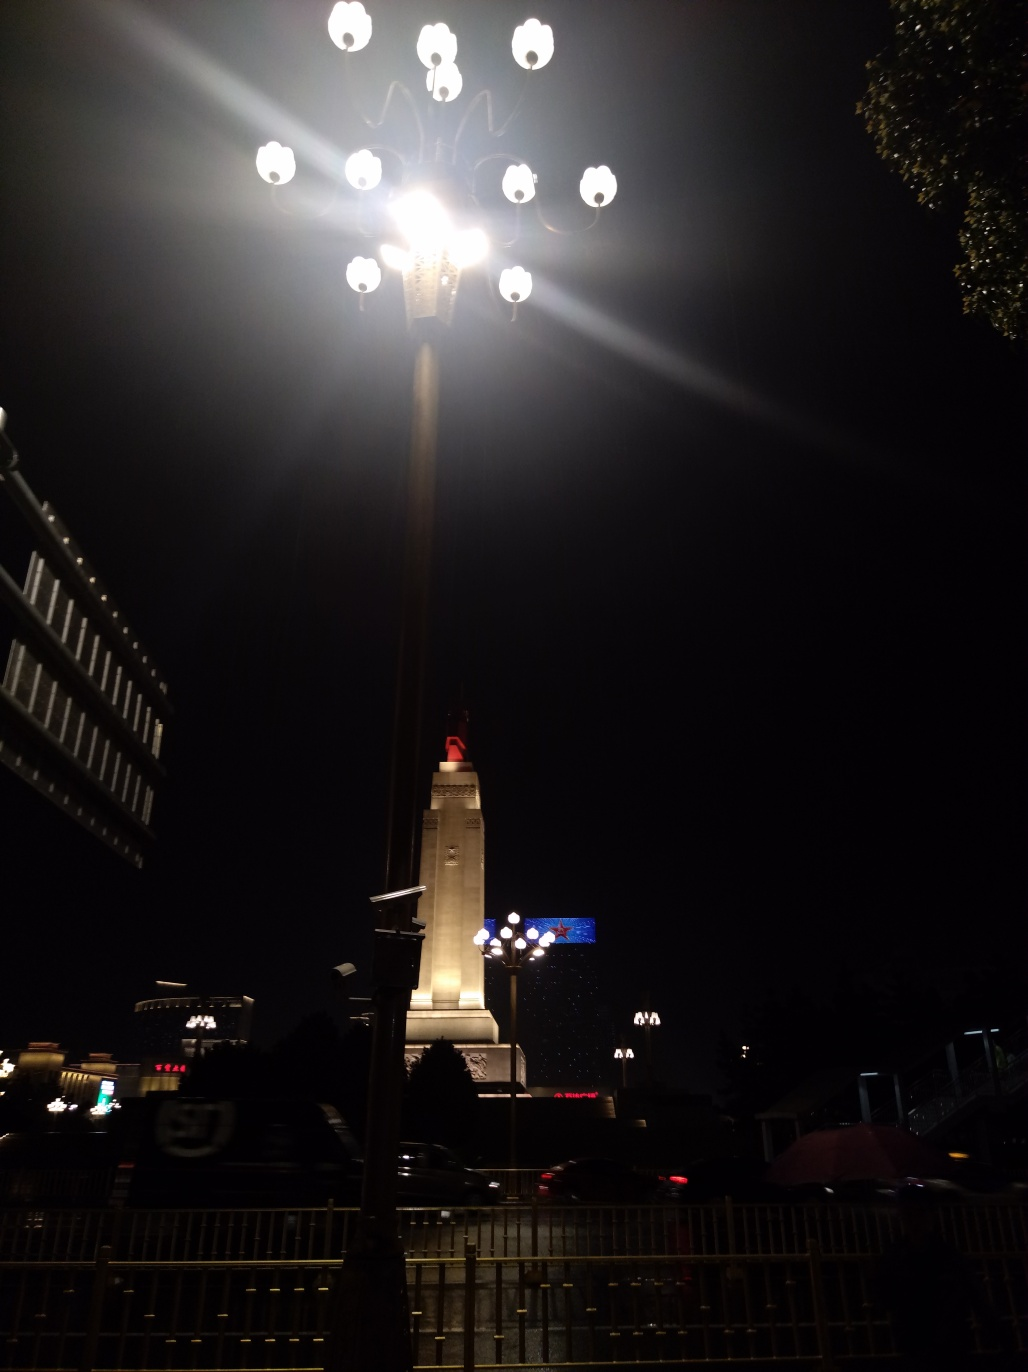Are there any focus issues in this image?
A. yes
B. occasionally
C. rarely
D. no
Answer with the option's letter from the given choices directly.
 D. 